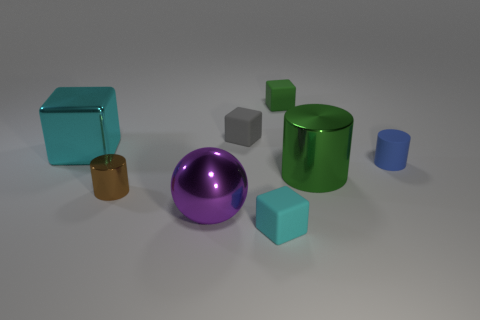How many other things are there of the same material as the tiny gray thing?
Your response must be concise. 3. How many other objects are there of the same size as the blue cylinder?
Your answer should be very brief. 4. How big is the cyan thing left of the brown metallic object in front of the tiny blue matte cylinder?
Make the answer very short. Large. There is a tiny cylinder that is on the left side of the small cylinder that is behind the shiny thing that is on the right side of the green rubber thing; what is its color?
Provide a short and direct response. Brown. How big is the cylinder that is on the right side of the purple object and left of the matte cylinder?
Ensure brevity in your answer.  Large. What number of other objects are there of the same shape as the small cyan object?
Provide a succinct answer. 3. How many cubes are cyan things or small cyan matte things?
Make the answer very short. 2. Are there any tiny matte blocks that are behind the big shiny thing to the left of the large shiny thing that is in front of the tiny metallic thing?
Your response must be concise. Yes. There is a tiny shiny object that is the same shape as the tiny blue matte object; what color is it?
Your answer should be compact. Brown. How many yellow objects are large cubes or tiny matte cylinders?
Provide a short and direct response. 0. 